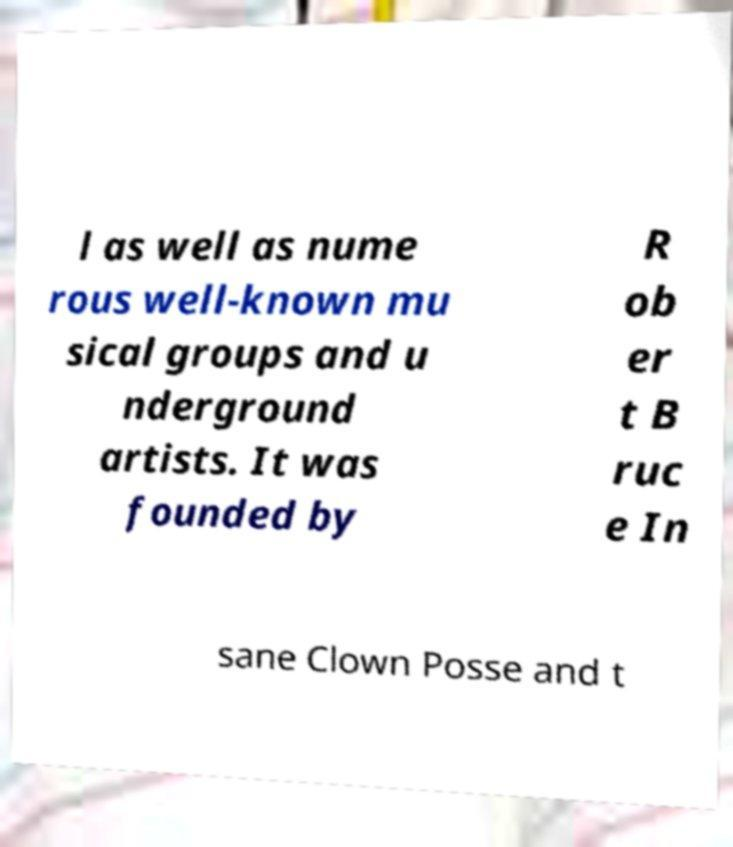Can you read and provide the text displayed in the image?This photo seems to have some interesting text. Can you extract and type it out for me? l as well as nume rous well-known mu sical groups and u nderground artists. It was founded by R ob er t B ruc e In sane Clown Posse and t 